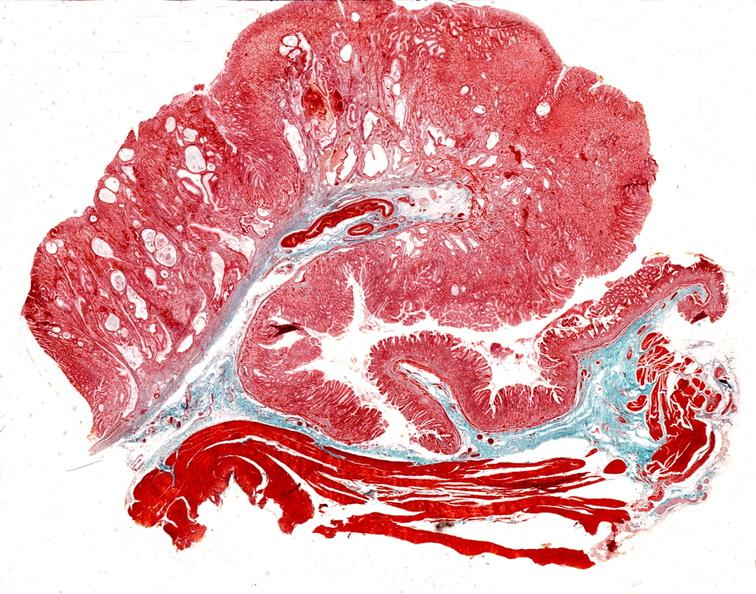does this image show stomach, giant rugose hyperplasia?
Answer the question using a single word or phrase. Yes 